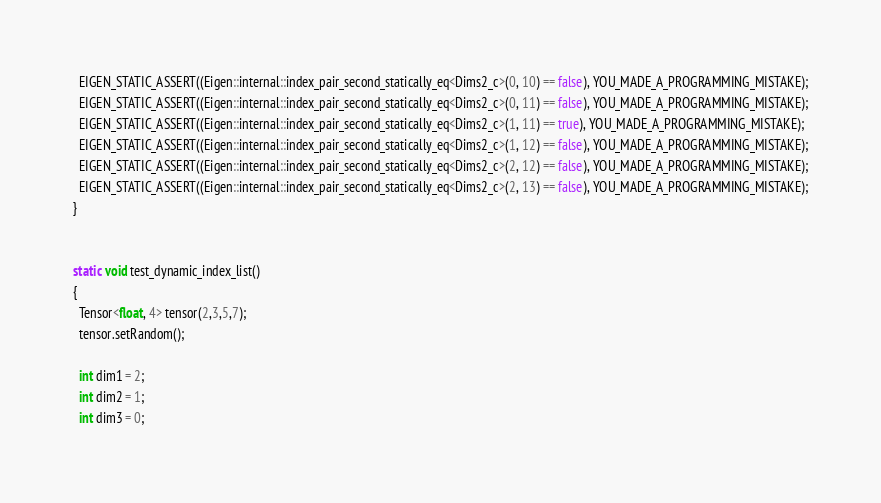<code> <loc_0><loc_0><loc_500><loc_500><_C++_>
  EIGEN_STATIC_ASSERT((Eigen::internal::index_pair_second_statically_eq<Dims2_c>(0, 10) == false), YOU_MADE_A_PROGRAMMING_MISTAKE);
  EIGEN_STATIC_ASSERT((Eigen::internal::index_pair_second_statically_eq<Dims2_c>(0, 11) == false), YOU_MADE_A_PROGRAMMING_MISTAKE);
  EIGEN_STATIC_ASSERT((Eigen::internal::index_pair_second_statically_eq<Dims2_c>(1, 11) == true), YOU_MADE_A_PROGRAMMING_MISTAKE);
  EIGEN_STATIC_ASSERT((Eigen::internal::index_pair_second_statically_eq<Dims2_c>(1, 12) == false), YOU_MADE_A_PROGRAMMING_MISTAKE);
  EIGEN_STATIC_ASSERT((Eigen::internal::index_pair_second_statically_eq<Dims2_c>(2, 12) == false), YOU_MADE_A_PROGRAMMING_MISTAKE);
  EIGEN_STATIC_ASSERT((Eigen::internal::index_pair_second_statically_eq<Dims2_c>(2, 13) == false), YOU_MADE_A_PROGRAMMING_MISTAKE);
}


static void test_dynamic_index_list()
{
  Tensor<float, 4> tensor(2,3,5,7);
  tensor.setRandom();

  int dim1 = 2;
  int dim2 = 1;
  int dim3 = 0;
</code> 